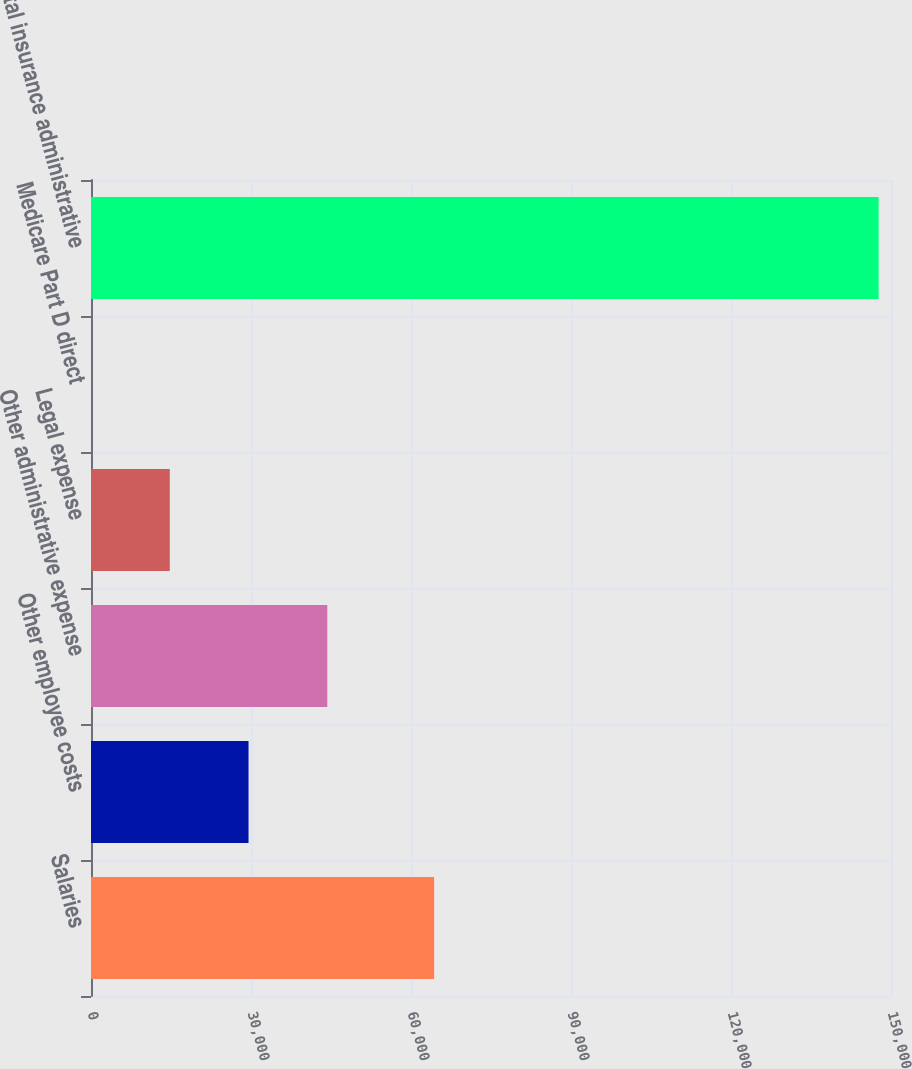Convert chart to OTSL. <chart><loc_0><loc_0><loc_500><loc_500><bar_chart><fcel>Salaries<fcel>Other employee costs<fcel>Other administrative expense<fcel>Legal expense<fcel>Medicare Part D direct<fcel>Total insurance administrative<nl><fcel>64339<fcel>29539<fcel>44306.7<fcel>14771.2<fcel>3.47<fcel>147681<nl></chart> 